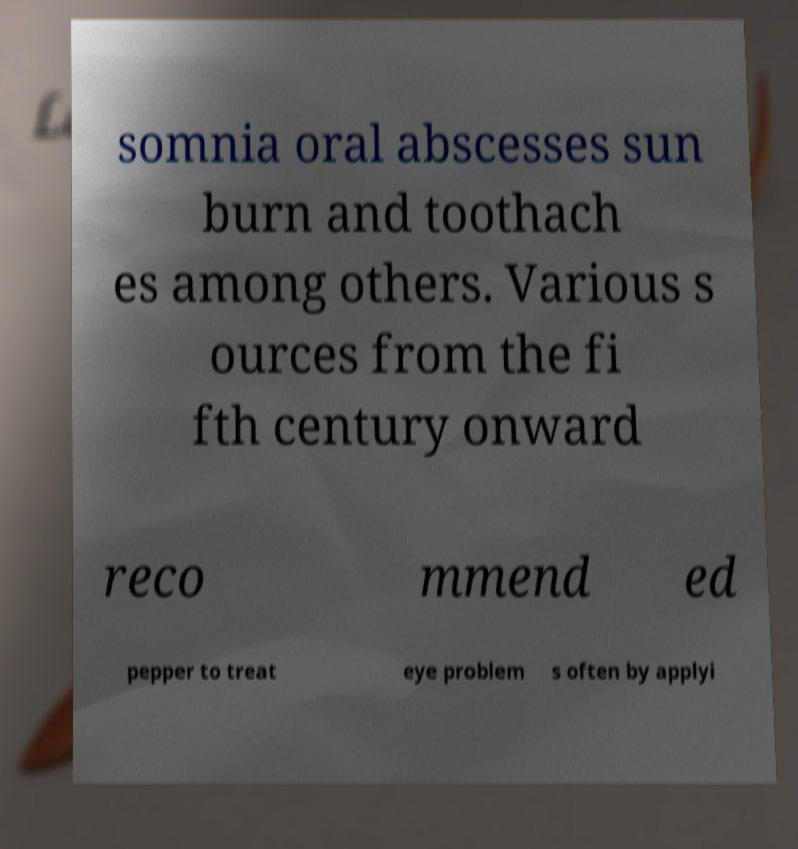Please read and relay the text visible in this image. What does it say? somnia oral abscesses sun burn and toothach es among others. Various s ources from the fi fth century onward reco mmend ed pepper to treat eye problem s often by applyi 